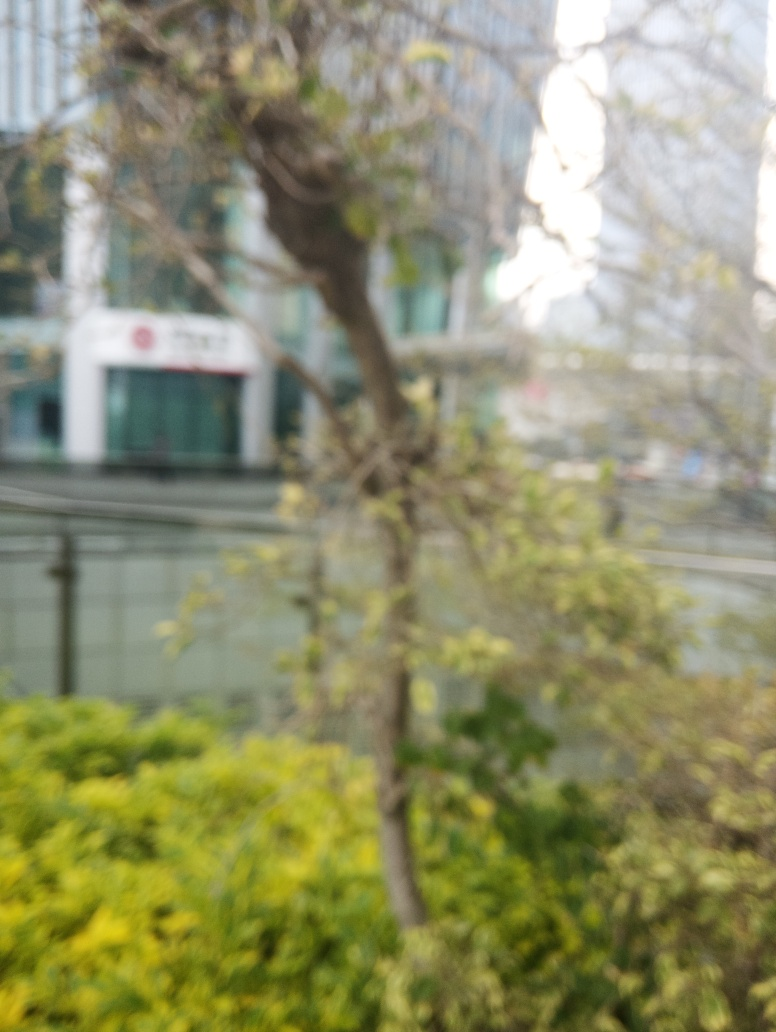Can you clearly see the details of the branches and leaves? Given the noticeable blurriness and lack of sharpness in the image, it's not possible to discern the intricate details of the branches and leaves. The focus appears to be off, which causes a general softness over the entire scene, obscuring the finer attributes of the vegetation. 